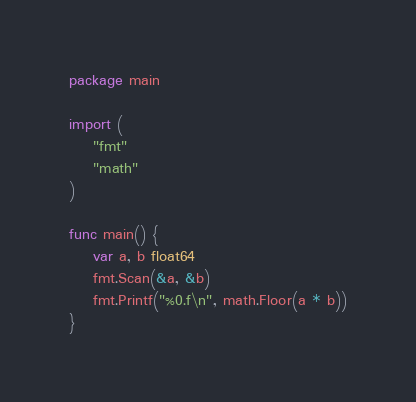Convert code to text. <code><loc_0><loc_0><loc_500><loc_500><_Go_>package main

import (
	"fmt"
	"math"
)

func main() {
	var a, b float64
	fmt.Scan(&a, &b)
	fmt.Printf("%0.f\n", math.Floor(a * b))
}
</code> 